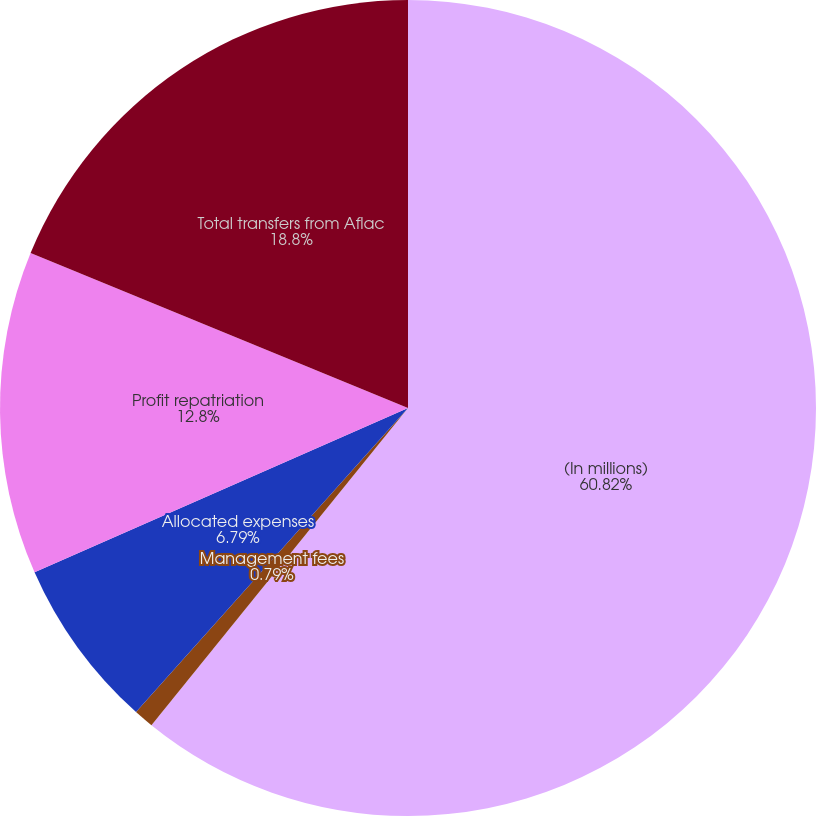Convert chart to OTSL. <chart><loc_0><loc_0><loc_500><loc_500><pie_chart><fcel>(In millions)<fcel>Management fees<fcel>Allocated expenses<fcel>Profit repatriation<fcel>Total transfers from Aflac<nl><fcel>60.83%<fcel>0.79%<fcel>6.79%<fcel>12.8%<fcel>18.8%<nl></chart> 